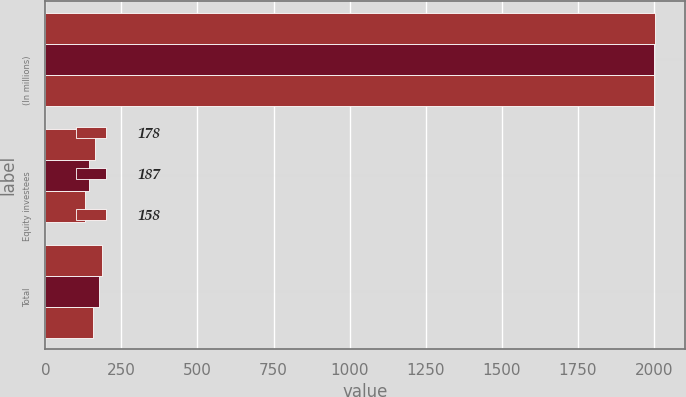Convert chart to OTSL. <chart><loc_0><loc_0><loc_500><loc_500><stacked_bar_chart><ecel><fcel>(In millions)<fcel>Equity investees<fcel>Total<nl><fcel>178<fcel>2003<fcel>163<fcel>187<nl><fcel>187<fcel>2002<fcel>145<fcel>178<nl><fcel>158<fcel>2001<fcel>129<fcel>158<nl></chart> 